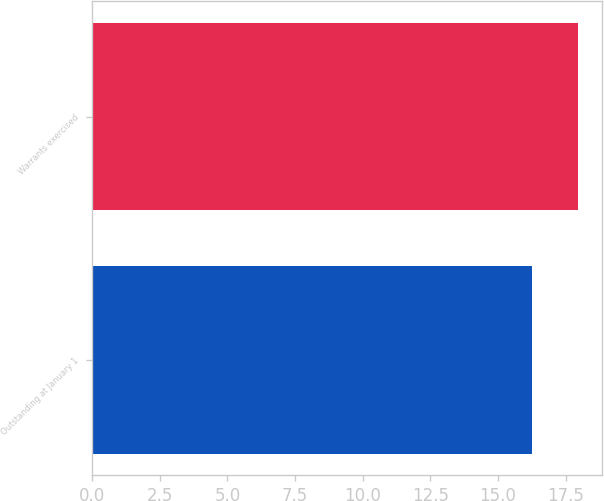Convert chart. <chart><loc_0><loc_0><loc_500><loc_500><bar_chart><fcel>Outstanding at January 1<fcel>Warrants exercised<nl><fcel>16.24<fcel>17.96<nl></chart> 